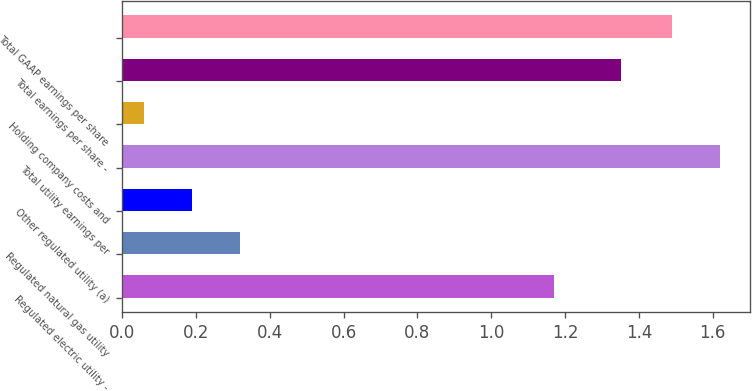Convert chart to OTSL. <chart><loc_0><loc_0><loc_500><loc_500><bar_chart><fcel>Regulated electric utility -<fcel>Regulated natural gas utility<fcel>Other regulated utility (a)<fcel>Total utility earnings per<fcel>Holding company costs and<fcel>Total earnings per share -<fcel>Total GAAP earnings per share<nl><fcel>1.17<fcel>0.32<fcel>0.19<fcel>1.62<fcel>0.06<fcel>1.35<fcel>1.49<nl></chart> 